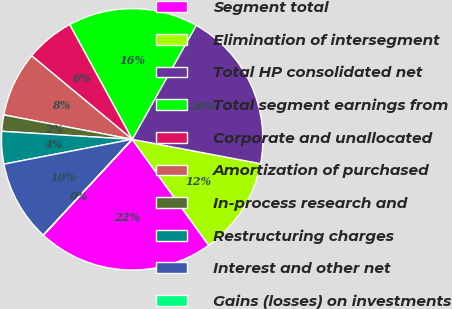Convert chart to OTSL. <chart><loc_0><loc_0><loc_500><loc_500><pie_chart><fcel>Segment total<fcel>Elimination of intersegment<fcel>Total HP consolidated net<fcel>Total segment earnings from<fcel>Corporate and unallocated<fcel>Amortization of purchased<fcel>In-process research and<fcel>Restructuring charges<fcel>Interest and other net<fcel>Gains (losses) on investments<nl><fcel>21.85%<fcel>12.06%<fcel>19.84%<fcel>16.08%<fcel>6.03%<fcel>8.04%<fcel>2.01%<fcel>4.02%<fcel>10.05%<fcel>0.01%<nl></chart> 